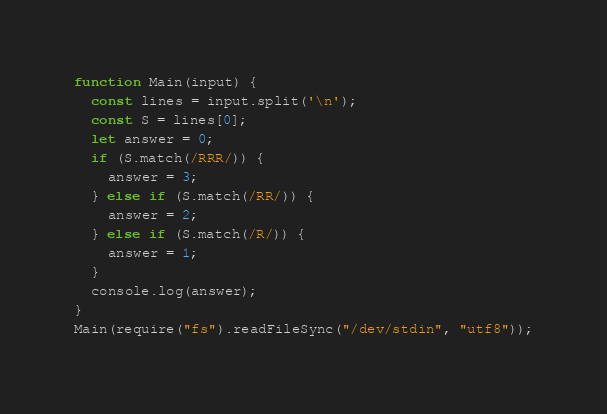Convert code to text. <code><loc_0><loc_0><loc_500><loc_500><_JavaScript_>function Main(input) {
  const lines = input.split('\n');
  const S = lines[0];
  let answer = 0;
  if (S.match(/RRR/)) {
    answer = 3;
  } else if (S.match(/RR/)) {
    answer = 2;
  } else if (S.match(/R/)) {
    answer = 1;
  }
  console.log(answer);
}
Main(require("fs").readFileSync("/dev/stdin", "utf8"));
</code> 